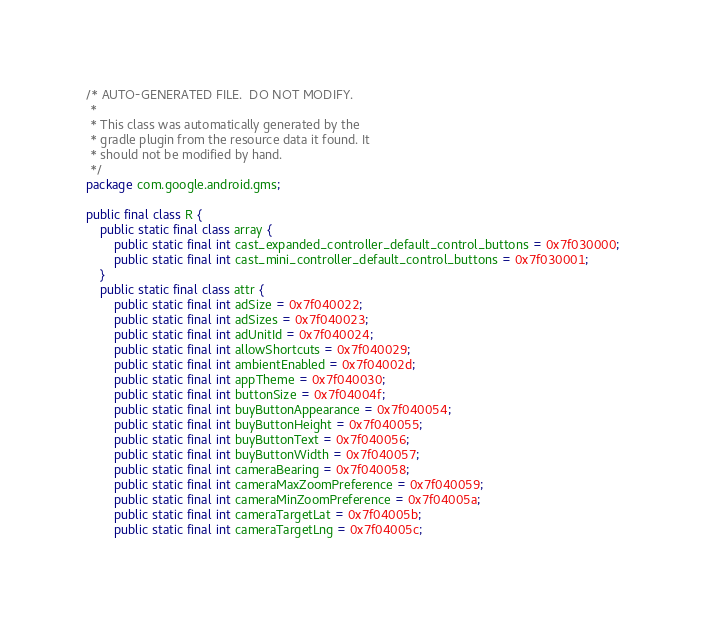Convert code to text. <code><loc_0><loc_0><loc_500><loc_500><_Java_>/* AUTO-GENERATED FILE.  DO NOT MODIFY.
 *
 * This class was automatically generated by the
 * gradle plugin from the resource data it found. It
 * should not be modified by hand.
 */
package com.google.android.gms;

public final class R {
    public static final class array {
        public static final int cast_expanded_controller_default_control_buttons = 0x7f030000;
        public static final int cast_mini_controller_default_control_buttons = 0x7f030001;
    }
    public static final class attr {
        public static final int adSize = 0x7f040022;
        public static final int adSizes = 0x7f040023;
        public static final int adUnitId = 0x7f040024;
        public static final int allowShortcuts = 0x7f040029;
        public static final int ambientEnabled = 0x7f04002d;
        public static final int appTheme = 0x7f040030;
        public static final int buttonSize = 0x7f04004f;
        public static final int buyButtonAppearance = 0x7f040054;
        public static final int buyButtonHeight = 0x7f040055;
        public static final int buyButtonText = 0x7f040056;
        public static final int buyButtonWidth = 0x7f040057;
        public static final int cameraBearing = 0x7f040058;
        public static final int cameraMaxZoomPreference = 0x7f040059;
        public static final int cameraMinZoomPreference = 0x7f04005a;
        public static final int cameraTargetLat = 0x7f04005b;
        public static final int cameraTargetLng = 0x7f04005c;</code> 